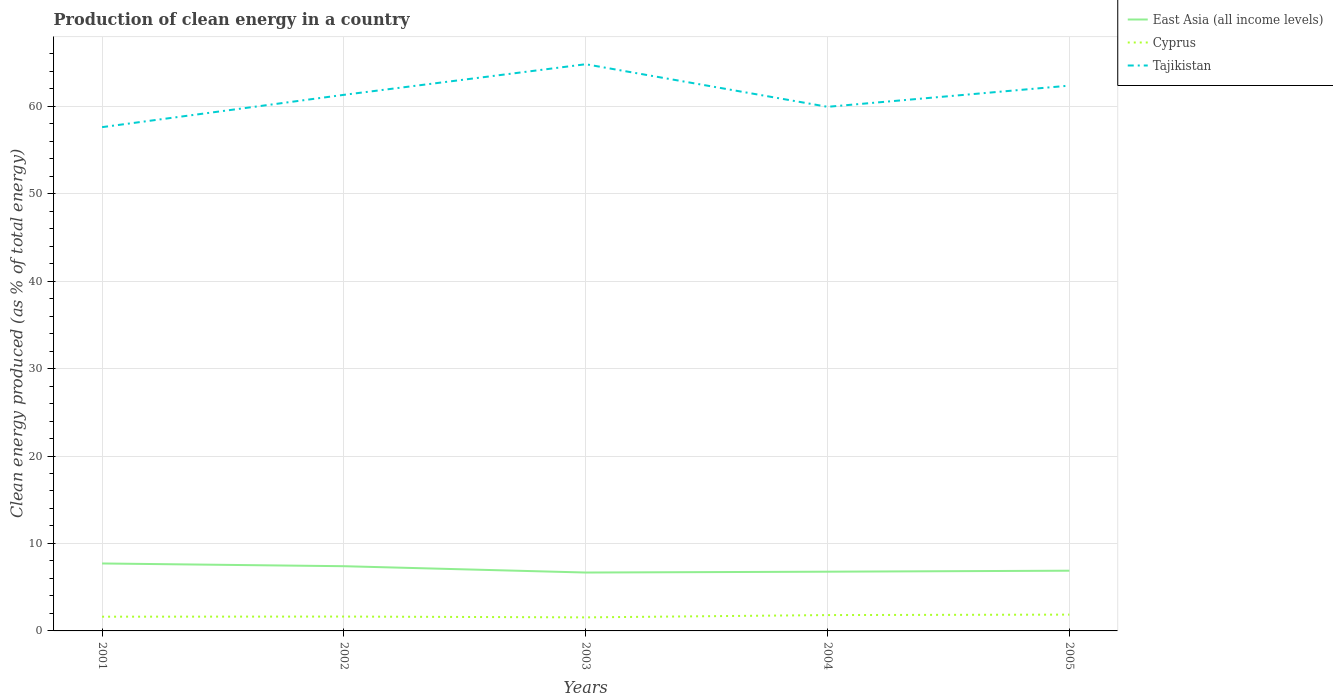Does the line corresponding to Tajikistan intersect with the line corresponding to Cyprus?
Offer a terse response. No. Is the number of lines equal to the number of legend labels?
Give a very brief answer. Yes. Across all years, what is the maximum percentage of clean energy produced in Cyprus?
Ensure brevity in your answer.  1.55. In which year was the percentage of clean energy produced in Tajikistan maximum?
Your response must be concise. 2001. What is the total percentage of clean energy produced in Cyprus in the graph?
Keep it short and to the point. -0.26. What is the difference between the highest and the second highest percentage of clean energy produced in East Asia (all income levels)?
Offer a terse response. 1.04. What is the difference between the highest and the lowest percentage of clean energy produced in Cyprus?
Offer a very short reply. 2. Is the percentage of clean energy produced in Cyprus strictly greater than the percentage of clean energy produced in Tajikistan over the years?
Provide a succinct answer. Yes. How many lines are there?
Offer a very short reply. 3. Are the values on the major ticks of Y-axis written in scientific E-notation?
Provide a succinct answer. No. Where does the legend appear in the graph?
Offer a very short reply. Top right. How are the legend labels stacked?
Your answer should be compact. Vertical. What is the title of the graph?
Your response must be concise. Production of clean energy in a country. What is the label or title of the Y-axis?
Your response must be concise. Clean energy produced (as % of total energy). What is the Clean energy produced (as % of total energy) in East Asia (all income levels) in 2001?
Provide a short and direct response. 7.71. What is the Clean energy produced (as % of total energy) in Cyprus in 2001?
Make the answer very short. 1.63. What is the Clean energy produced (as % of total energy) in Tajikistan in 2001?
Keep it short and to the point. 57.61. What is the Clean energy produced (as % of total energy) of East Asia (all income levels) in 2002?
Offer a very short reply. 7.4. What is the Clean energy produced (as % of total energy) in Cyprus in 2002?
Make the answer very short. 1.64. What is the Clean energy produced (as % of total energy) of Tajikistan in 2002?
Your response must be concise. 61.3. What is the Clean energy produced (as % of total energy) in East Asia (all income levels) in 2003?
Provide a succinct answer. 6.68. What is the Clean energy produced (as % of total energy) in Cyprus in 2003?
Give a very brief answer. 1.55. What is the Clean energy produced (as % of total energy) in Tajikistan in 2003?
Your answer should be very brief. 64.8. What is the Clean energy produced (as % of total energy) in East Asia (all income levels) in 2004?
Make the answer very short. 6.77. What is the Clean energy produced (as % of total energy) in Cyprus in 2004?
Provide a succinct answer. 1.81. What is the Clean energy produced (as % of total energy) of Tajikistan in 2004?
Your answer should be very brief. 59.93. What is the Clean energy produced (as % of total energy) of East Asia (all income levels) in 2005?
Offer a terse response. 6.89. What is the Clean energy produced (as % of total energy) of Cyprus in 2005?
Give a very brief answer. 1.86. What is the Clean energy produced (as % of total energy) of Tajikistan in 2005?
Provide a succinct answer. 62.35. Across all years, what is the maximum Clean energy produced (as % of total energy) of East Asia (all income levels)?
Provide a succinct answer. 7.71. Across all years, what is the maximum Clean energy produced (as % of total energy) of Cyprus?
Ensure brevity in your answer.  1.86. Across all years, what is the maximum Clean energy produced (as % of total energy) in Tajikistan?
Make the answer very short. 64.8. Across all years, what is the minimum Clean energy produced (as % of total energy) in East Asia (all income levels)?
Ensure brevity in your answer.  6.68. Across all years, what is the minimum Clean energy produced (as % of total energy) of Cyprus?
Offer a very short reply. 1.55. Across all years, what is the minimum Clean energy produced (as % of total energy) in Tajikistan?
Give a very brief answer. 57.61. What is the total Clean energy produced (as % of total energy) in East Asia (all income levels) in the graph?
Make the answer very short. 35.45. What is the total Clean energy produced (as % of total energy) in Cyprus in the graph?
Make the answer very short. 8.5. What is the total Clean energy produced (as % of total energy) in Tajikistan in the graph?
Make the answer very short. 305.99. What is the difference between the Clean energy produced (as % of total energy) in East Asia (all income levels) in 2001 and that in 2002?
Make the answer very short. 0.31. What is the difference between the Clean energy produced (as % of total energy) of Cyprus in 2001 and that in 2002?
Make the answer very short. -0.01. What is the difference between the Clean energy produced (as % of total energy) in Tajikistan in 2001 and that in 2002?
Offer a very short reply. -3.69. What is the difference between the Clean energy produced (as % of total energy) in East Asia (all income levels) in 2001 and that in 2003?
Provide a short and direct response. 1.04. What is the difference between the Clean energy produced (as % of total energy) of Cyprus in 2001 and that in 2003?
Offer a very short reply. 0.08. What is the difference between the Clean energy produced (as % of total energy) in Tajikistan in 2001 and that in 2003?
Provide a succinct answer. -7.19. What is the difference between the Clean energy produced (as % of total energy) in East Asia (all income levels) in 2001 and that in 2004?
Your response must be concise. 0.94. What is the difference between the Clean energy produced (as % of total energy) in Cyprus in 2001 and that in 2004?
Ensure brevity in your answer.  -0.19. What is the difference between the Clean energy produced (as % of total energy) in Tajikistan in 2001 and that in 2004?
Keep it short and to the point. -2.32. What is the difference between the Clean energy produced (as % of total energy) in East Asia (all income levels) in 2001 and that in 2005?
Your answer should be compact. 0.83. What is the difference between the Clean energy produced (as % of total energy) in Cyprus in 2001 and that in 2005?
Make the answer very short. -0.24. What is the difference between the Clean energy produced (as % of total energy) of Tajikistan in 2001 and that in 2005?
Provide a short and direct response. -4.75. What is the difference between the Clean energy produced (as % of total energy) in East Asia (all income levels) in 2002 and that in 2003?
Provide a succinct answer. 0.72. What is the difference between the Clean energy produced (as % of total energy) of Cyprus in 2002 and that in 2003?
Your answer should be very brief. 0.09. What is the difference between the Clean energy produced (as % of total energy) of Tajikistan in 2002 and that in 2003?
Offer a terse response. -3.5. What is the difference between the Clean energy produced (as % of total energy) in East Asia (all income levels) in 2002 and that in 2004?
Your answer should be very brief. 0.63. What is the difference between the Clean energy produced (as % of total energy) of Cyprus in 2002 and that in 2004?
Offer a terse response. -0.17. What is the difference between the Clean energy produced (as % of total energy) of Tajikistan in 2002 and that in 2004?
Your answer should be compact. 1.37. What is the difference between the Clean energy produced (as % of total energy) of East Asia (all income levels) in 2002 and that in 2005?
Make the answer very short. 0.51. What is the difference between the Clean energy produced (as % of total energy) of Cyprus in 2002 and that in 2005?
Keep it short and to the point. -0.22. What is the difference between the Clean energy produced (as % of total energy) in Tajikistan in 2002 and that in 2005?
Provide a short and direct response. -1.05. What is the difference between the Clean energy produced (as % of total energy) of East Asia (all income levels) in 2003 and that in 2004?
Your response must be concise. -0.1. What is the difference between the Clean energy produced (as % of total energy) in Cyprus in 2003 and that in 2004?
Make the answer very short. -0.26. What is the difference between the Clean energy produced (as % of total energy) in Tajikistan in 2003 and that in 2004?
Your answer should be very brief. 4.87. What is the difference between the Clean energy produced (as % of total energy) of East Asia (all income levels) in 2003 and that in 2005?
Your response must be concise. -0.21. What is the difference between the Clean energy produced (as % of total energy) of Cyprus in 2003 and that in 2005?
Ensure brevity in your answer.  -0.31. What is the difference between the Clean energy produced (as % of total energy) in Tajikistan in 2003 and that in 2005?
Make the answer very short. 2.45. What is the difference between the Clean energy produced (as % of total energy) of East Asia (all income levels) in 2004 and that in 2005?
Your response must be concise. -0.11. What is the difference between the Clean energy produced (as % of total energy) in Cyprus in 2004 and that in 2005?
Keep it short and to the point. -0.05. What is the difference between the Clean energy produced (as % of total energy) in Tajikistan in 2004 and that in 2005?
Give a very brief answer. -2.42. What is the difference between the Clean energy produced (as % of total energy) in East Asia (all income levels) in 2001 and the Clean energy produced (as % of total energy) in Cyprus in 2002?
Make the answer very short. 6.07. What is the difference between the Clean energy produced (as % of total energy) of East Asia (all income levels) in 2001 and the Clean energy produced (as % of total energy) of Tajikistan in 2002?
Offer a very short reply. -53.59. What is the difference between the Clean energy produced (as % of total energy) in Cyprus in 2001 and the Clean energy produced (as % of total energy) in Tajikistan in 2002?
Your answer should be very brief. -59.67. What is the difference between the Clean energy produced (as % of total energy) of East Asia (all income levels) in 2001 and the Clean energy produced (as % of total energy) of Cyprus in 2003?
Provide a succinct answer. 6.16. What is the difference between the Clean energy produced (as % of total energy) in East Asia (all income levels) in 2001 and the Clean energy produced (as % of total energy) in Tajikistan in 2003?
Offer a very short reply. -57.09. What is the difference between the Clean energy produced (as % of total energy) of Cyprus in 2001 and the Clean energy produced (as % of total energy) of Tajikistan in 2003?
Your answer should be compact. -63.17. What is the difference between the Clean energy produced (as % of total energy) of East Asia (all income levels) in 2001 and the Clean energy produced (as % of total energy) of Cyprus in 2004?
Make the answer very short. 5.9. What is the difference between the Clean energy produced (as % of total energy) in East Asia (all income levels) in 2001 and the Clean energy produced (as % of total energy) in Tajikistan in 2004?
Provide a succinct answer. -52.22. What is the difference between the Clean energy produced (as % of total energy) in Cyprus in 2001 and the Clean energy produced (as % of total energy) in Tajikistan in 2004?
Your answer should be very brief. -58.3. What is the difference between the Clean energy produced (as % of total energy) of East Asia (all income levels) in 2001 and the Clean energy produced (as % of total energy) of Cyprus in 2005?
Provide a short and direct response. 5.85. What is the difference between the Clean energy produced (as % of total energy) in East Asia (all income levels) in 2001 and the Clean energy produced (as % of total energy) in Tajikistan in 2005?
Offer a terse response. -54.64. What is the difference between the Clean energy produced (as % of total energy) in Cyprus in 2001 and the Clean energy produced (as % of total energy) in Tajikistan in 2005?
Your answer should be very brief. -60.73. What is the difference between the Clean energy produced (as % of total energy) of East Asia (all income levels) in 2002 and the Clean energy produced (as % of total energy) of Cyprus in 2003?
Provide a succinct answer. 5.85. What is the difference between the Clean energy produced (as % of total energy) in East Asia (all income levels) in 2002 and the Clean energy produced (as % of total energy) in Tajikistan in 2003?
Provide a short and direct response. -57.4. What is the difference between the Clean energy produced (as % of total energy) in Cyprus in 2002 and the Clean energy produced (as % of total energy) in Tajikistan in 2003?
Ensure brevity in your answer.  -63.16. What is the difference between the Clean energy produced (as % of total energy) in East Asia (all income levels) in 2002 and the Clean energy produced (as % of total energy) in Cyprus in 2004?
Provide a succinct answer. 5.59. What is the difference between the Clean energy produced (as % of total energy) in East Asia (all income levels) in 2002 and the Clean energy produced (as % of total energy) in Tajikistan in 2004?
Give a very brief answer. -52.53. What is the difference between the Clean energy produced (as % of total energy) in Cyprus in 2002 and the Clean energy produced (as % of total energy) in Tajikistan in 2004?
Your answer should be compact. -58.29. What is the difference between the Clean energy produced (as % of total energy) in East Asia (all income levels) in 2002 and the Clean energy produced (as % of total energy) in Cyprus in 2005?
Provide a succinct answer. 5.54. What is the difference between the Clean energy produced (as % of total energy) in East Asia (all income levels) in 2002 and the Clean energy produced (as % of total energy) in Tajikistan in 2005?
Your answer should be very brief. -54.95. What is the difference between the Clean energy produced (as % of total energy) of Cyprus in 2002 and the Clean energy produced (as % of total energy) of Tajikistan in 2005?
Your answer should be very brief. -60.71. What is the difference between the Clean energy produced (as % of total energy) in East Asia (all income levels) in 2003 and the Clean energy produced (as % of total energy) in Cyprus in 2004?
Ensure brevity in your answer.  4.86. What is the difference between the Clean energy produced (as % of total energy) of East Asia (all income levels) in 2003 and the Clean energy produced (as % of total energy) of Tajikistan in 2004?
Offer a very short reply. -53.25. What is the difference between the Clean energy produced (as % of total energy) in Cyprus in 2003 and the Clean energy produced (as % of total energy) in Tajikistan in 2004?
Provide a short and direct response. -58.38. What is the difference between the Clean energy produced (as % of total energy) in East Asia (all income levels) in 2003 and the Clean energy produced (as % of total energy) in Cyprus in 2005?
Provide a succinct answer. 4.81. What is the difference between the Clean energy produced (as % of total energy) of East Asia (all income levels) in 2003 and the Clean energy produced (as % of total energy) of Tajikistan in 2005?
Offer a very short reply. -55.68. What is the difference between the Clean energy produced (as % of total energy) in Cyprus in 2003 and the Clean energy produced (as % of total energy) in Tajikistan in 2005?
Offer a terse response. -60.81. What is the difference between the Clean energy produced (as % of total energy) in East Asia (all income levels) in 2004 and the Clean energy produced (as % of total energy) in Cyprus in 2005?
Ensure brevity in your answer.  4.91. What is the difference between the Clean energy produced (as % of total energy) of East Asia (all income levels) in 2004 and the Clean energy produced (as % of total energy) of Tajikistan in 2005?
Make the answer very short. -55.58. What is the difference between the Clean energy produced (as % of total energy) in Cyprus in 2004 and the Clean energy produced (as % of total energy) in Tajikistan in 2005?
Your answer should be very brief. -60.54. What is the average Clean energy produced (as % of total energy) of East Asia (all income levels) per year?
Offer a terse response. 7.09. What is the average Clean energy produced (as % of total energy) of Cyprus per year?
Give a very brief answer. 1.7. What is the average Clean energy produced (as % of total energy) of Tajikistan per year?
Make the answer very short. 61.2. In the year 2001, what is the difference between the Clean energy produced (as % of total energy) of East Asia (all income levels) and Clean energy produced (as % of total energy) of Cyprus?
Ensure brevity in your answer.  6.09. In the year 2001, what is the difference between the Clean energy produced (as % of total energy) of East Asia (all income levels) and Clean energy produced (as % of total energy) of Tajikistan?
Give a very brief answer. -49.89. In the year 2001, what is the difference between the Clean energy produced (as % of total energy) of Cyprus and Clean energy produced (as % of total energy) of Tajikistan?
Keep it short and to the point. -55.98. In the year 2002, what is the difference between the Clean energy produced (as % of total energy) of East Asia (all income levels) and Clean energy produced (as % of total energy) of Cyprus?
Ensure brevity in your answer.  5.76. In the year 2002, what is the difference between the Clean energy produced (as % of total energy) in East Asia (all income levels) and Clean energy produced (as % of total energy) in Tajikistan?
Make the answer very short. -53.9. In the year 2002, what is the difference between the Clean energy produced (as % of total energy) in Cyprus and Clean energy produced (as % of total energy) in Tajikistan?
Your answer should be very brief. -59.66. In the year 2003, what is the difference between the Clean energy produced (as % of total energy) in East Asia (all income levels) and Clean energy produced (as % of total energy) in Cyprus?
Offer a terse response. 5.13. In the year 2003, what is the difference between the Clean energy produced (as % of total energy) of East Asia (all income levels) and Clean energy produced (as % of total energy) of Tajikistan?
Provide a succinct answer. -58.12. In the year 2003, what is the difference between the Clean energy produced (as % of total energy) of Cyprus and Clean energy produced (as % of total energy) of Tajikistan?
Provide a succinct answer. -63.25. In the year 2004, what is the difference between the Clean energy produced (as % of total energy) in East Asia (all income levels) and Clean energy produced (as % of total energy) in Cyprus?
Provide a short and direct response. 4.96. In the year 2004, what is the difference between the Clean energy produced (as % of total energy) of East Asia (all income levels) and Clean energy produced (as % of total energy) of Tajikistan?
Provide a succinct answer. -53.16. In the year 2004, what is the difference between the Clean energy produced (as % of total energy) of Cyprus and Clean energy produced (as % of total energy) of Tajikistan?
Your answer should be compact. -58.12. In the year 2005, what is the difference between the Clean energy produced (as % of total energy) in East Asia (all income levels) and Clean energy produced (as % of total energy) in Cyprus?
Provide a short and direct response. 5.02. In the year 2005, what is the difference between the Clean energy produced (as % of total energy) of East Asia (all income levels) and Clean energy produced (as % of total energy) of Tajikistan?
Give a very brief answer. -55.47. In the year 2005, what is the difference between the Clean energy produced (as % of total energy) in Cyprus and Clean energy produced (as % of total energy) in Tajikistan?
Offer a terse response. -60.49. What is the ratio of the Clean energy produced (as % of total energy) in East Asia (all income levels) in 2001 to that in 2002?
Your answer should be compact. 1.04. What is the ratio of the Clean energy produced (as % of total energy) of Cyprus in 2001 to that in 2002?
Your answer should be very brief. 0.99. What is the ratio of the Clean energy produced (as % of total energy) of Tajikistan in 2001 to that in 2002?
Keep it short and to the point. 0.94. What is the ratio of the Clean energy produced (as % of total energy) in East Asia (all income levels) in 2001 to that in 2003?
Your answer should be very brief. 1.16. What is the ratio of the Clean energy produced (as % of total energy) of Cyprus in 2001 to that in 2003?
Offer a very short reply. 1.05. What is the ratio of the Clean energy produced (as % of total energy) in Tajikistan in 2001 to that in 2003?
Provide a short and direct response. 0.89. What is the ratio of the Clean energy produced (as % of total energy) of East Asia (all income levels) in 2001 to that in 2004?
Your answer should be compact. 1.14. What is the ratio of the Clean energy produced (as % of total energy) in Cyprus in 2001 to that in 2004?
Your response must be concise. 0.9. What is the ratio of the Clean energy produced (as % of total energy) in Tajikistan in 2001 to that in 2004?
Ensure brevity in your answer.  0.96. What is the ratio of the Clean energy produced (as % of total energy) of East Asia (all income levels) in 2001 to that in 2005?
Your answer should be very brief. 1.12. What is the ratio of the Clean energy produced (as % of total energy) of Cyprus in 2001 to that in 2005?
Ensure brevity in your answer.  0.87. What is the ratio of the Clean energy produced (as % of total energy) in Tajikistan in 2001 to that in 2005?
Ensure brevity in your answer.  0.92. What is the ratio of the Clean energy produced (as % of total energy) in East Asia (all income levels) in 2002 to that in 2003?
Ensure brevity in your answer.  1.11. What is the ratio of the Clean energy produced (as % of total energy) of Cyprus in 2002 to that in 2003?
Ensure brevity in your answer.  1.06. What is the ratio of the Clean energy produced (as % of total energy) in Tajikistan in 2002 to that in 2003?
Your answer should be very brief. 0.95. What is the ratio of the Clean energy produced (as % of total energy) in East Asia (all income levels) in 2002 to that in 2004?
Your response must be concise. 1.09. What is the ratio of the Clean energy produced (as % of total energy) of Cyprus in 2002 to that in 2004?
Offer a terse response. 0.91. What is the ratio of the Clean energy produced (as % of total energy) in Tajikistan in 2002 to that in 2004?
Ensure brevity in your answer.  1.02. What is the ratio of the Clean energy produced (as % of total energy) of East Asia (all income levels) in 2002 to that in 2005?
Keep it short and to the point. 1.07. What is the ratio of the Clean energy produced (as % of total energy) of Cyprus in 2002 to that in 2005?
Your answer should be very brief. 0.88. What is the ratio of the Clean energy produced (as % of total energy) of Tajikistan in 2002 to that in 2005?
Provide a succinct answer. 0.98. What is the ratio of the Clean energy produced (as % of total energy) in East Asia (all income levels) in 2003 to that in 2004?
Give a very brief answer. 0.99. What is the ratio of the Clean energy produced (as % of total energy) of Cyprus in 2003 to that in 2004?
Offer a terse response. 0.85. What is the ratio of the Clean energy produced (as % of total energy) of Tajikistan in 2003 to that in 2004?
Provide a short and direct response. 1.08. What is the ratio of the Clean energy produced (as % of total energy) in East Asia (all income levels) in 2003 to that in 2005?
Offer a terse response. 0.97. What is the ratio of the Clean energy produced (as % of total energy) of Cyprus in 2003 to that in 2005?
Provide a succinct answer. 0.83. What is the ratio of the Clean energy produced (as % of total energy) in Tajikistan in 2003 to that in 2005?
Give a very brief answer. 1.04. What is the ratio of the Clean energy produced (as % of total energy) in East Asia (all income levels) in 2004 to that in 2005?
Offer a terse response. 0.98. What is the ratio of the Clean energy produced (as % of total energy) in Cyprus in 2004 to that in 2005?
Your answer should be very brief. 0.97. What is the ratio of the Clean energy produced (as % of total energy) in Tajikistan in 2004 to that in 2005?
Offer a terse response. 0.96. What is the difference between the highest and the second highest Clean energy produced (as % of total energy) in East Asia (all income levels)?
Your answer should be very brief. 0.31. What is the difference between the highest and the second highest Clean energy produced (as % of total energy) of Cyprus?
Give a very brief answer. 0.05. What is the difference between the highest and the second highest Clean energy produced (as % of total energy) in Tajikistan?
Give a very brief answer. 2.45. What is the difference between the highest and the lowest Clean energy produced (as % of total energy) of East Asia (all income levels)?
Your answer should be very brief. 1.04. What is the difference between the highest and the lowest Clean energy produced (as % of total energy) of Cyprus?
Provide a short and direct response. 0.31. What is the difference between the highest and the lowest Clean energy produced (as % of total energy) in Tajikistan?
Provide a short and direct response. 7.19. 